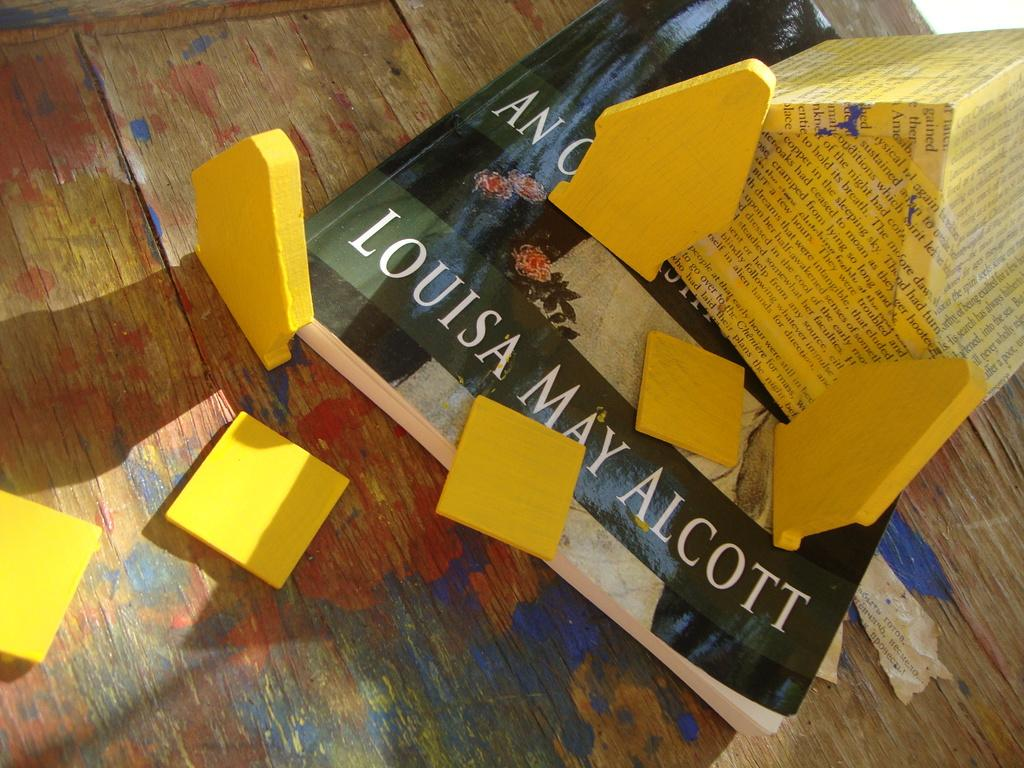<image>
Provide a brief description of the given image. A yellow toy house on top a book by Louisa May Alcott 